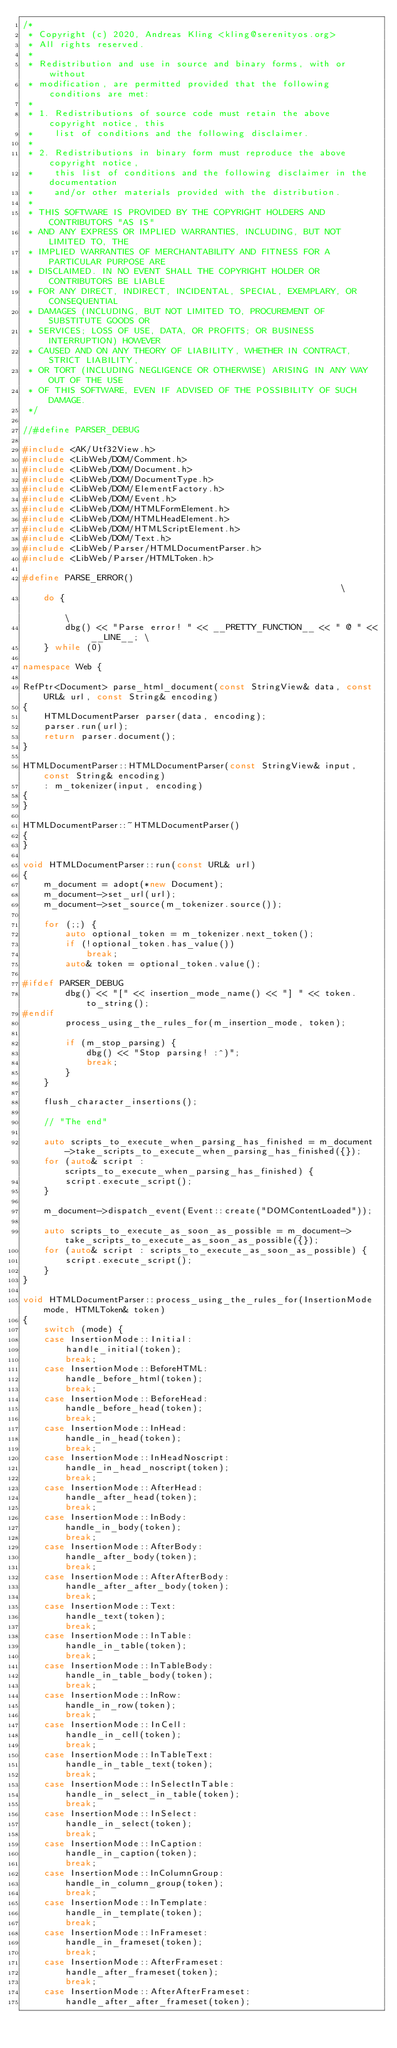<code> <loc_0><loc_0><loc_500><loc_500><_C++_>/*
 * Copyright (c) 2020, Andreas Kling <kling@serenityos.org>
 * All rights reserved.
 *
 * Redistribution and use in source and binary forms, with or without
 * modification, are permitted provided that the following conditions are met:
 *
 * 1. Redistributions of source code must retain the above copyright notice, this
 *    list of conditions and the following disclaimer.
 *
 * 2. Redistributions in binary form must reproduce the above copyright notice,
 *    this list of conditions and the following disclaimer in the documentation
 *    and/or other materials provided with the distribution.
 *
 * THIS SOFTWARE IS PROVIDED BY THE COPYRIGHT HOLDERS AND CONTRIBUTORS "AS IS"
 * AND ANY EXPRESS OR IMPLIED WARRANTIES, INCLUDING, BUT NOT LIMITED TO, THE
 * IMPLIED WARRANTIES OF MERCHANTABILITY AND FITNESS FOR A PARTICULAR PURPOSE ARE
 * DISCLAIMED. IN NO EVENT SHALL THE COPYRIGHT HOLDER OR CONTRIBUTORS BE LIABLE
 * FOR ANY DIRECT, INDIRECT, INCIDENTAL, SPECIAL, EXEMPLARY, OR CONSEQUENTIAL
 * DAMAGES (INCLUDING, BUT NOT LIMITED TO, PROCUREMENT OF SUBSTITUTE GOODS OR
 * SERVICES; LOSS OF USE, DATA, OR PROFITS; OR BUSINESS INTERRUPTION) HOWEVER
 * CAUSED AND ON ANY THEORY OF LIABILITY, WHETHER IN CONTRACT, STRICT LIABILITY,
 * OR TORT (INCLUDING NEGLIGENCE OR OTHERWISE) ARISING IN ANY WAY OUT OF THE USE
 * OF THIS SOFTWARE, EVEN IF ADVISED OF THE POSSIBILITY OF SUCH DAMAGE.
 */

//#define PARSER_DEBUG

#include <AK/Utf32View.h>
#include <LibWeb/DOM/Comment.h>
#include <LibWeb/DOM/Document.h>
#include <LibWeb/DOM/DocumentType.h>
#include <LibWeb/DOM/ElementFactory.h>
#include <LibWeb/DOM/Event.h>
#include <LibWeb/DOM/HTMLFormElement.h>
#include <LibWeb/DOM/HTMLHeadElement.h>
#include <LibWeb/DOM/HTMLScriptElement.h>
#include <LibWeb/DOM/Text.h>
#include <LibWeb/Parser/HTMLDocumentParser.h>
#include <LibWeb/Parser/HTMLToken.h>

#define PARSE_ERROR()                                                         \
    do {                                                                      \
        dbg() << "Parse error! " << __PRETTY_FUNCTION__ << " @ " << __LINE__; \
    } while (0)

namespace Web {

RefPtr<Document> parse_html_document(const StringView& data, const URL& url, const String& encoding)
{
    HTMLDocumentParser parser(data, encoding);
    parser.run(url);
    return parser.document();
}

HTMLDocumentParser::HTMLDocumentParser(const StringView& input, const String& encoding)
    : m_tokenizer(input, encoding)
{
}

HTMLDocumentParser::~HTMLDocumentParser()
{
}

void HTMLDocumentParser::run(const URL& url)
{
    m_document = adopt(*new Document);
    m_document->set_url(url);
    m_document->set_source(m_tokenizer.source());

    for (;;) {
        auto optional_token = m_tokenizer.next_token();
        if (!optional_token.has_value())
            break;
        auto& token = optional_token.value();

#ifdef PARSER_DEBUG
        dbg() << "[" << insertion_mode_name() << "] " << token.to_string();
#endif
        process_using_the_rules_for(m_insertion_mode, token);

        if (m_stop_parsing) {
            dbg() << "Stop parsing! :^)";
            break;
        }
    }

    flush_character_insertions();

    // "The end"

    auto scripts_to_execute_when_parsing_has_finished = m_document->take_scripts_to_execute_when_parsing_has_finished({});
    for (auto& script : scripts_to_execute_when_parsing_has_finished) {
        script.execute_script();
    }

    m_document->dispatch_event(Event::create("DOMContentLoaded"));

    auto scripts_to_execute_as_soon_as_possible = m_document->take_scripts_to_execute_as_soon_as_possible({});
    for (auto& script : scripts_to_execute_as_soon_as_possible) {
        script.execute_script();
    }
}

void HTMLDocumentParser::process_using_the_rules_for(InsertionMode mode, HTMLToken& token)
{
    switch (mode) {
    case InsertionMode::Initial:
        handle_initial(token);
        break;
    case InsertionMode::BeforeHTML:
        handle_before_html(token);
        break;
    case InsertionMode::BeforeHead:
        handle_before_head(token);
        break;
    case InsertionMode::InHead:
        handle_in_head(token);
        break;
    case InsertionMode::InHeadNoscript:
        handle_in_head_noscript(token);
        break;
    case InsertionMode::AfterHead:
        handle_after_head(token);
        break;
    case InsertionMode::InBody:
        handle_in_body(token);
        break;
    case InsertionMode::AfterBody:
        handle_after_body(token);
        break;
    case InsertionMode::AfterAfterBody:
        handle_after_after_body(token);
        break;
    case InsertionMode::Text:
        handle_text(token);
        break;
    case InsertionMode::InTable:
        handle_in_table(token);
        break;
    case InsertionMode::InTableBody:
        handle_in_table_body(token);
        break;
    case InsertionMode::InRow:
        handle_in_row(token);
        break;
    case InsertionMode::InCell:
        handle_in_cell(token);
        break;
    case InsertionMode::InTableText:
        handle_in_table_text(token);
        break;
    case InsertionMode::InSelectInTable:
        handle_in_select_in_table(token);
        break;
    case InsertionMode::InSelect:
        handle_in_select(token);
        break;
    case InsertionMode::InCaption:
        handle_in_caption(token);
        break;
    case InsertionMode::InColumnGroup:
        handle_in_column_group(token);
        break;
    case InsertionMode::InTemplate:
        handle_in_template(token);
        break;
    case InsertionMode::InFrameset:
        handle_in_frameset(token);
        break;
    case InsertionMode::AfterFrameset:
        handle_after_frameset(token);
        break;
    case InsertionMode::AfterAfterFrameset:
        handle_after_after_frameset(token);</code> 